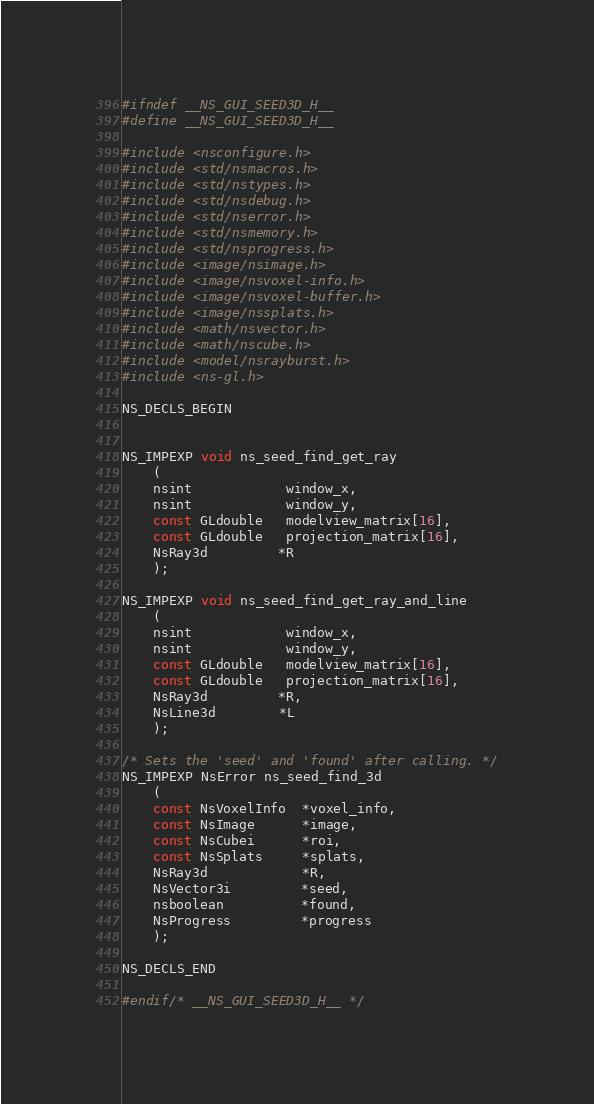<code> <loc_0><loc_0><loc_500><loc_500><_C_>#ifndef __NS_GUI_SEED3D_H__
#define __NS_GUI_SEED3D_H__

#include <nsconfigure.h>
#include <std/nsmacros.h>
#include <std/nstypes.h>
#include <std/nsdebug.h>
#include <std/nserror.h>
#include <std/nsmemory.h>
#include <std/nsprogress.h>
#include <image/nsimage.h>
#include <image/nsvoxel-info.h>
#include <image/nsvoxel-buffer.h>
#include <image/nssplats.h>
#include <math/nsvector.h>
#include <math/nscube.h>
#include <model/nsrayburst.h>
#include <ns-gl.h>

NS_DECLS_BEGIN


NS_IMPEXP void ns_seed_find_get_ray
	(
	nsint            window_x,
	nsint            window_y,
	const GLdouble   modelview_matrix[16],
	const GLdouble   projection_matrix[16],
	NsRay3d         *R
	);

NS_IMPEXP void ns_seed_find_get_ray_and_line
	(
	nsint            window_x,
	nsint            window_y,
	const GLdouble   modelview_matrix[16],
	const GLdouble   projection_matrix[16],
	NsRay3d         *R,
	NsLine3d        *L
	);

/* Sets the 'seed' and 'found' after calling. */
NS_IMPEXP NsError ns_seed_find_3d
	(
	const NsVoxelInfo  *voxel_info,
	const NsImage      *image,
	const NsCubei      *roi,
	const NsSplats     *splats,
	NsRay3d            *R,
	NsVector3i         *seed,
	nsboolean          *found,
	NsProgress         *progress
	);

NS_DECLS_END

#endif/* __NS_GUI_SEED3D_H__ */
</code> 